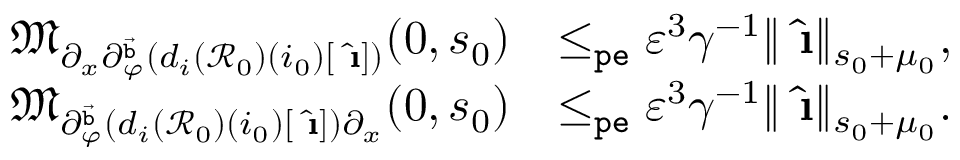Convert formula to latex. <formula><loc_0><loc_0><loc_500><loc_500>\begin{array} { r l } { \mathfrak { M } _ { \partial _ { x } \partial _ { \varphi } ^ { \vec { b } } ( d _ { i } ( \mathcal { R } _ { 0 } ) ( i _ { 0 } ) [ \hat { \i } ] ) } ( 0 , s _ { 0 } ) } & { \leq _ { p e } \varepsilon ^ { 3 } \gamma ^ { - 1 } \| \hat { \i } \| _ { s _ { 0 } + \mu _ { 0 } } , } \\ { \mathfrak { M } _ { \partial _ { \varphi } ^ { \vec { b } } ( d _ { i } ( \mathcal { R } _ { 0 } ) ( i _ { 0 } ) [ \hat { \i } ] ) \partial _ { x } } ( 0 , s _ { 0 } ) } & { \leq _ { p e } \varepsilon ^ { 3 } \gamma ^ { - 1 } \| \hat { \i } \| _ { s _ { 0 } + \mu _ { 0 } } . } \end{array}</formula> 